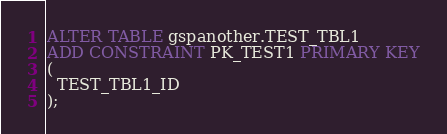Convert code to text. <code><loc_0><loc_0><loc_500><loc_500><_SQL_>ALTER TABLE gspanother.TEST_TBL1
ADD CONSTRAINT PK_TEST1 PRIMARY KEY
(
  TEST_TBL1_ID
);
</code> 